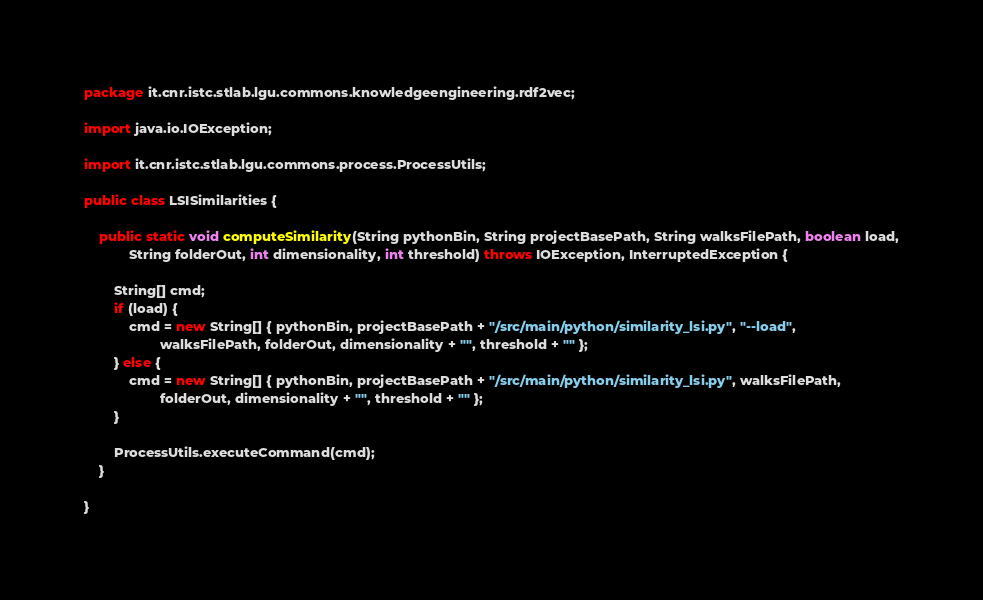Convert code to text. <code><loc_0><loc_0><loc_500><loc_500><_Java_>package it.cnr.istc.stlab.lgu.commons.knowledgeengineering.rdf2vec;

import java.io.IOException;

import it.cnr.istc.stlab.lgu.commons.process.ProcessUtils;

public class LSISimilarities {

	public static void computeSimilarity(String pythonBin, String projectBasePath, String walksFilePath, boolean load,
			String folderOut, int dimensionality, int threshold) throws IOException, InterruptedException {

		String[] cmd;
		if (load) {
			cmd = new String[] { pythonBin, projectBasePath + "/src/main/python/similarity_lsi.py", "--load",
					walksFilePath, folderOut, dimensionality + "", threshold + "" };
		} else {
			cmd = new String[] { pythonBin, projectBasePath + "/src/main/python/similarity_lsi.py", walksFilePath,
					folderOut, dimensionality + "", threshold + "" };
		}

		ProcessUtils.executeCommand(cmd);
	}

}
</code> 